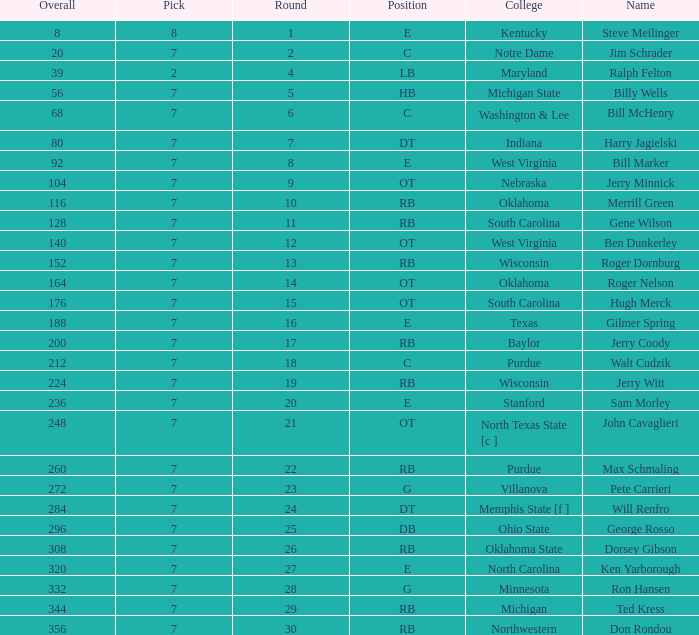What is the number of the round in which Ron Hansen was drafted and the overall is greater than 332? 0.0. 